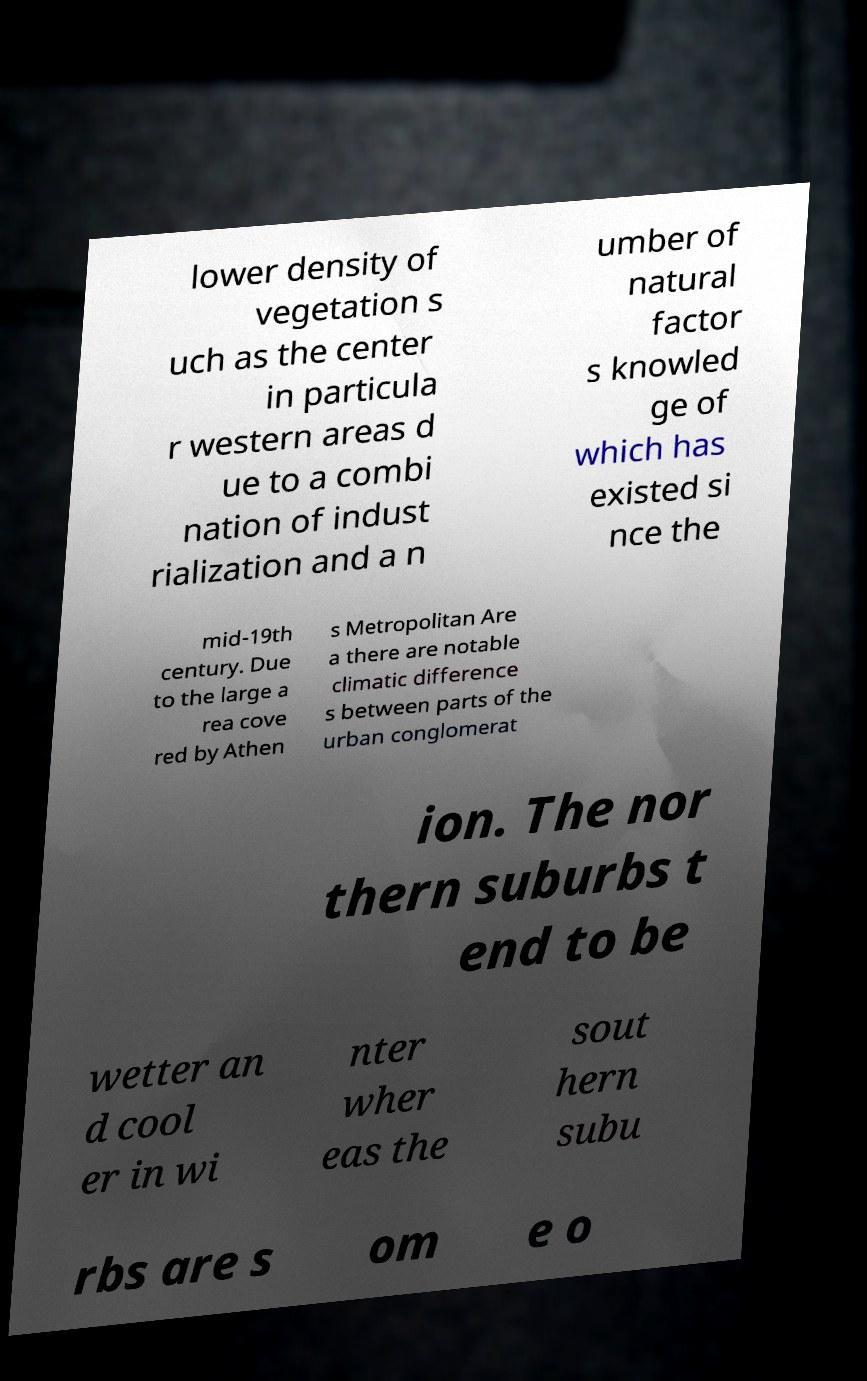Please read and relay the text visible in this image. What does it say? lower density of vegetation s uch as the center in particula r western areas d ue to a combi nation of indust rialization and a n umber of natural factor s knowled ge of which has existed si nce the mid-19th century. Due to the large a rea cove red by Athen s Metropolitan Are a there are notable climatic difference s between parts of the urban conglomerat ion. The nor thern suburbs t end to be wetter an d cool er in wi nter wher eas the sout hern subu rbs are s om e o 